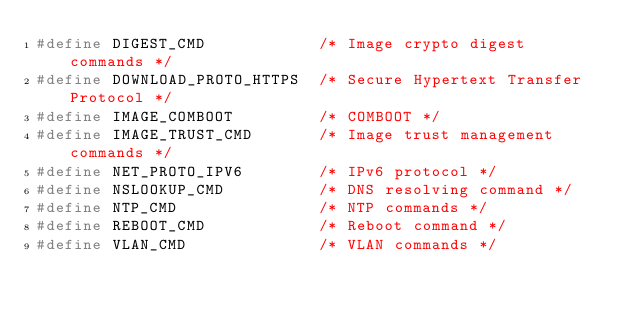<code> <loc_0><loc_0><loc_500><loc_500><_C_>#define DIGEST_CMD            /* Image crypto digest commands */
#define DOWNLOAD_PROTO_HTTPS  /* Secure Hypertext Transfer Protocol */      
#define IMAGE_COMBOOT         /* COMBOOT */
#define IMAGE_TRUST_CMD	      /* Image trust management commands */
#define NET_PROTO_IPV6        /* IPv6 protocol */
#define NSLOOKUP_CMD          /* DNS resolving command */
#define NTP_CMD               /* NTP commands */
#define REBOOT_CMD            /* Reboot command */
#define VLAN_CMD              /* VLAN commands */
</code> 